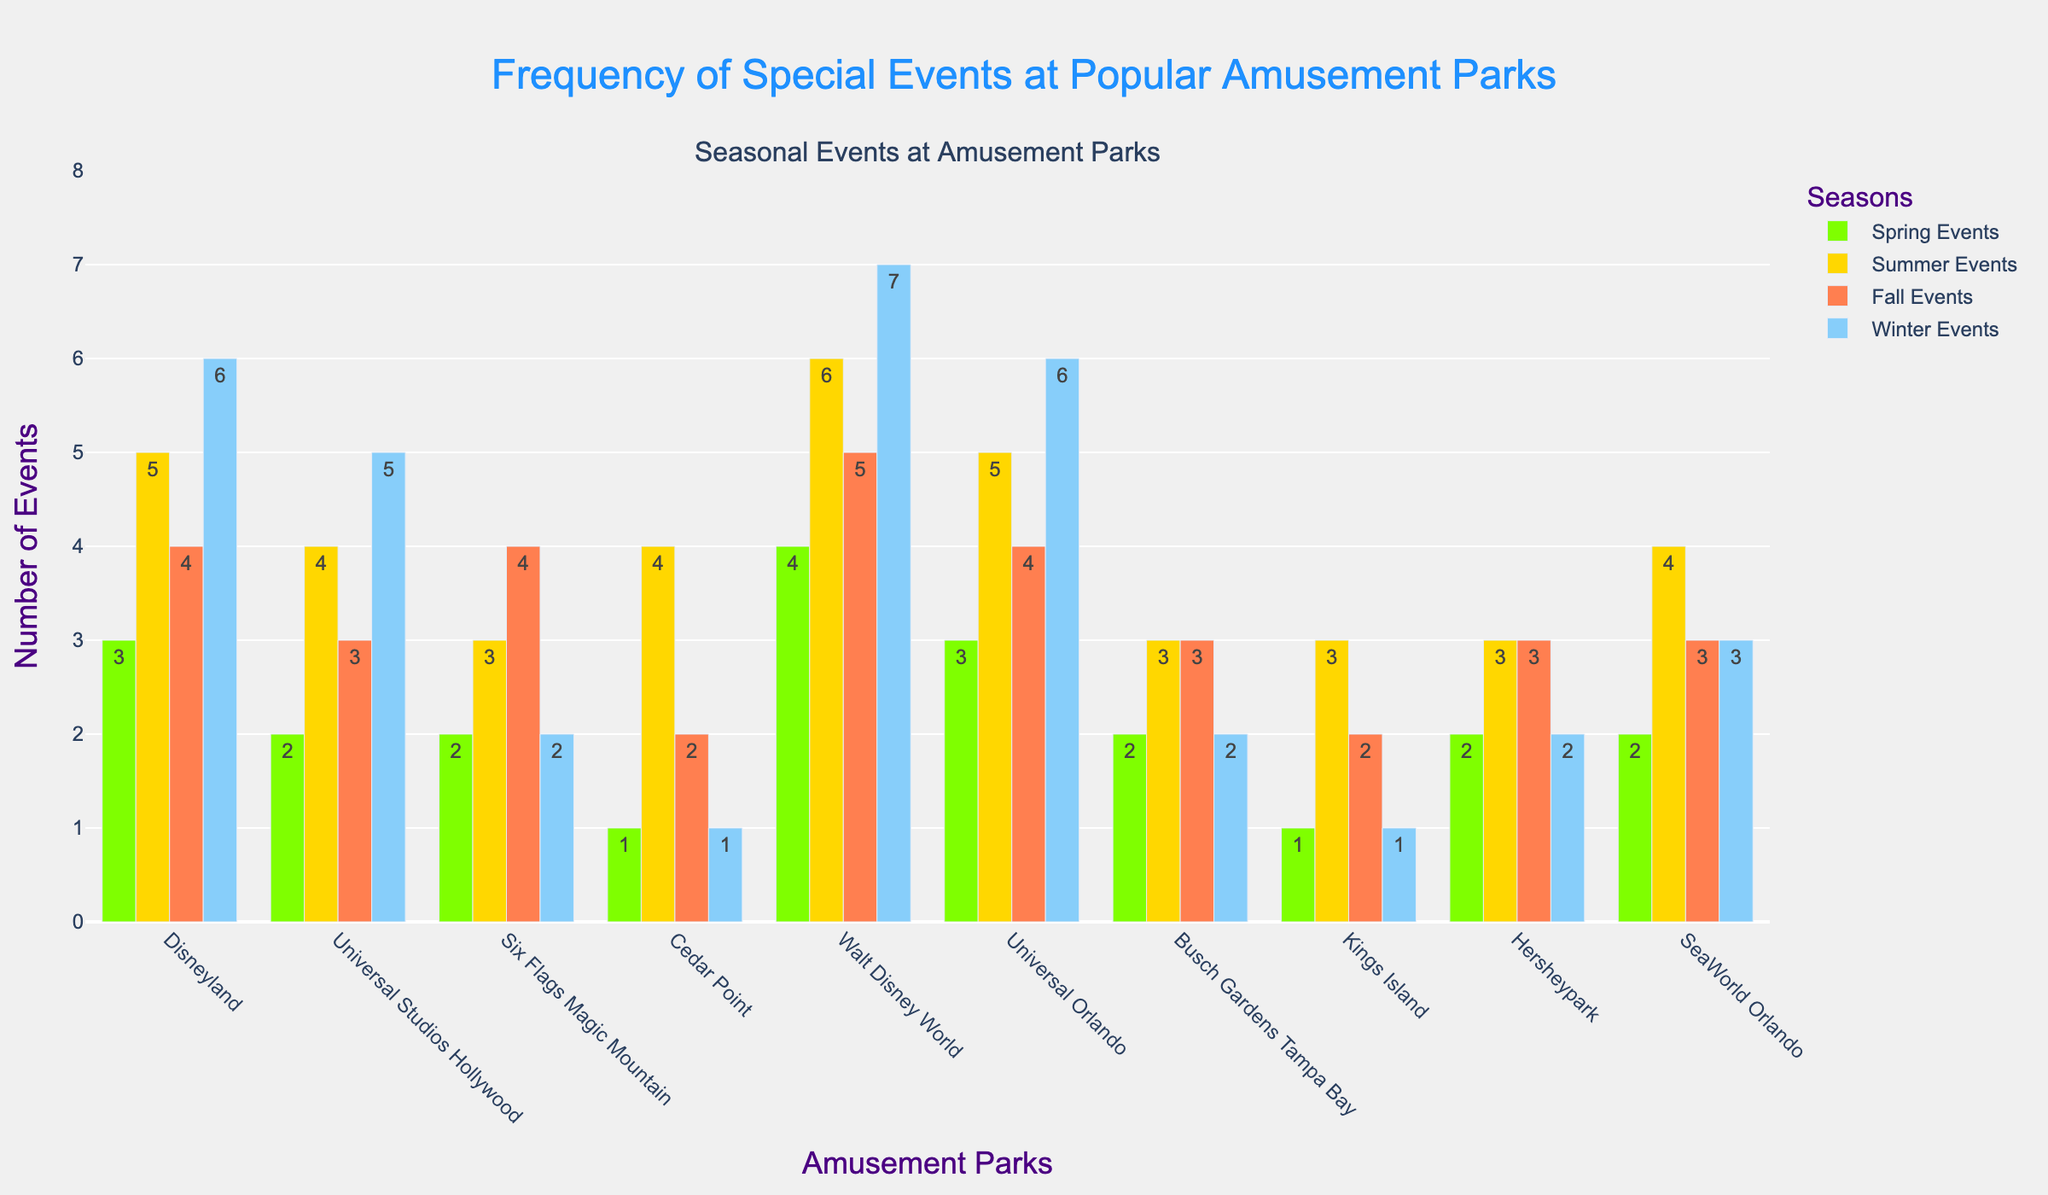What is the amusement park with the highest number of special events in winter? Look for the bars representing Winter Events for each amusement park and identify the tallest bar. Disney World and Universal Orlando both have the highest bar in Winter Events with 7 events each.
Answer: Walt Disney World Which amusement park has the least number of spring events? Compare the heights of the bars representing Spring Events for all parks. Kings Island and Cedar Point have the shortest bars, both with 1 event each.
Answer: Kings Island and Cedar Point What is the total number of summer events across all amusement parks? Add the values of Summer Events for all parks: 5 (Disneyland) + 4 (Universal Studios Hollywood) + 3 (Six Flags) + 4 (Cedar Point) + 6 (Disney World) + 5 (Universal Orlando) + 3 (Busch Gardens) + 3 (Kings Island) + 3 (Hersheypark) + 4 (SeaWorld). The total is 40.
Answer: 40 How many more fall events does Walt Disney World have compared to Busch Gardens Tampa Bay? Subtract the number of Fall Events at Busch Gardens Tampa Bay from the number at Walt Disney World: 5 (Disney World) - 3 (Busch Gardens) = 2.
Answer: 2 Which seasons have the most and the least number of events at Universal Studios Hollywood? Compare the heights of the bars representing each season's events at Universal Studios Hollywood. The tallest bar is for Summer Events (4) and the shortest bar is for Spring Events (2).
Answer: Most: Summer, Least: Spring What is the difference in the number of spring events between Disneyland and SeaWorld Orlando? Subtract the number of Spring Events at SeaWorld Orlando from the number at Disneyland: 3 (Disneyland) - 2 (SeaWorld) = 1.
Answer: 1 What is the visual difference in color between Spring Events and Fall Events bars? Describe the colors used for the bars representing Spring Events and Fall Events. Spring Events are represented by green bars, while Fall Events are represented by orange bars.
Answer: Green and Orange How many events are held in total at Six Flags Magic Mountain across all seasons? Sum the values of events for each season at Six Flags Magic Mountain: 2 (Spring) + 3 (Summer) + 4 (Fall) + 2 (Winter) = 11.
Answer: 11 Which amusement park holds the same number of winter events as spring events? Find parks where the bars for Winter and Spring Events are of equal height. Busch Gardens Tampa Bay, Six Flags Magic Mountain, and Kings Island each have 2 winter and 2 spring events.
Answer: Busch Gardens Tampa Bay, Six Flags Magic Mountain, and Kings Island 